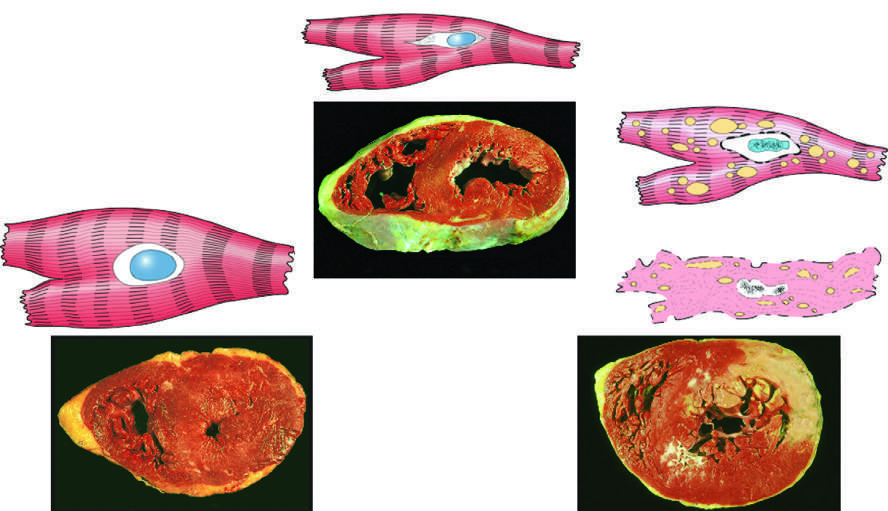what is thicker than 2 cm (normal, 1-1.5 cm) in the example of myocardial hypertrophy lower left?
Answer the question using a single word or phrase. The left ventricular wall 